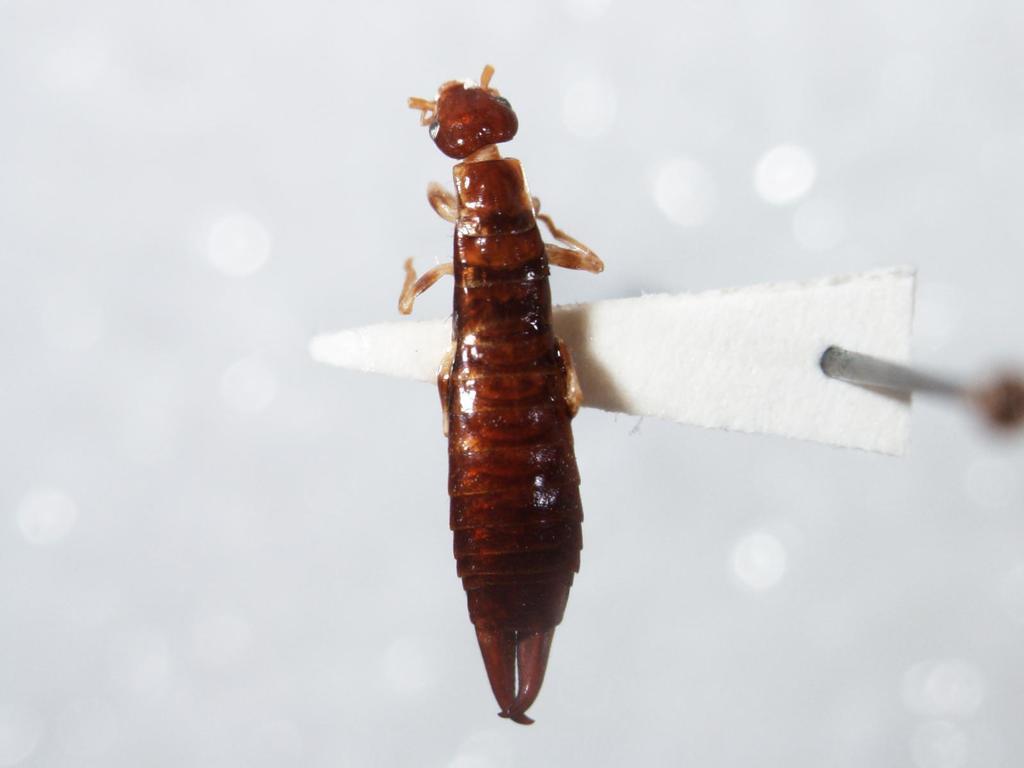Describe this image in one or two sentences. In this image, we can see an insect on the white color object. Background there is a blur view. 